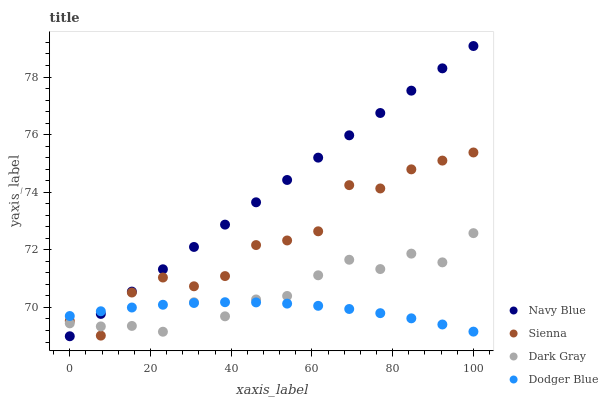Does Dodger Blue have the minimum area under the curve?
Answer yes or no. Yes. Does Navy Blue have the maximum area under the curve?
Answer yes or no. Yes. Does Dark Gray have the minimum area under the curve?
Answer yes or no. No. Does Dark Gray have the maximum area under the curve?
Answer yes or no. No. Is Navy Blue the smoothest?
Answer yes or no. Yes. Is Sienna the roughest?
Answer yes or no. Yes. Is Dark Gray the smoothest?
Answer yes or no. No. Is Dark Gray the roughest?
Answer yes or no. No. Does Navy Blue have the lowest value?
Answer yes or no. Yes. Does Dark Gray have the lowest value?
Answer yes or no. No. Does Navy Blue have the highest value?
Answer yes or no. Yes. Does Dark Gray have the highest value?
Answer yes or no. No. Does Sienna intersect Dark Gray?
Answer yes or no. Yes. Is Sienna less than Dark Gray?
Answer yes or no. No. Is Sienna greater than Dark Gray?
Answer yes or no. No. 